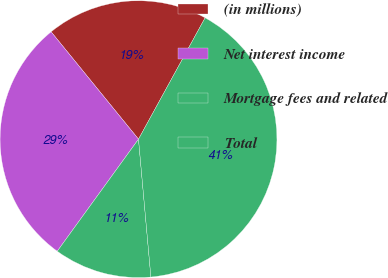Convert chart to OTSL. <chart><loc_0><loc_0><loc_500><loc_500><pie_chart><fcel>(in millions)<fcel>Net interest income<fcel>Mortgage fees and related<fcel>Total<nl><fcel>18.86%<fcel>29.14%<fcel>11.41%<fcel>40.58%<nl></chart> 